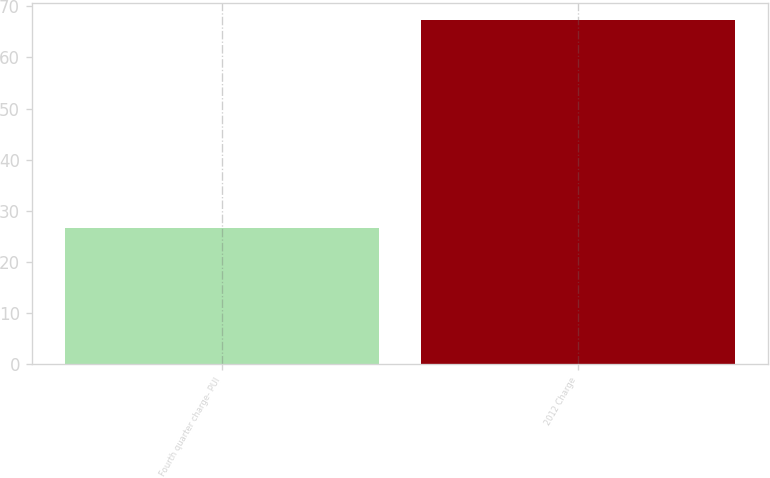Convert chart to OTSL. <chart><loc_0><loc_0><loc_500><loc_500><bar_chart><fcel>Fourth quarter charge- PUI<fcel>2012 Charge<nl><fcel>26.6<fcel>67.3<nl></chart> 